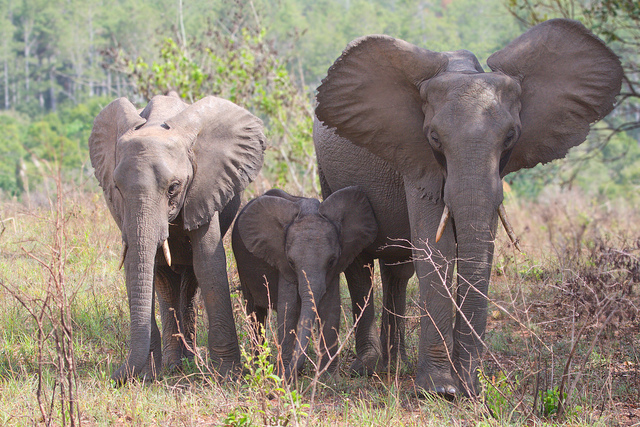How many elephants? There are 3 elephants in the image, consisting of one larger elephant that appears to be an adult, and two smaller elephants that are likely juveniles based on their size and proximity to the adult, suggesting a family group. 